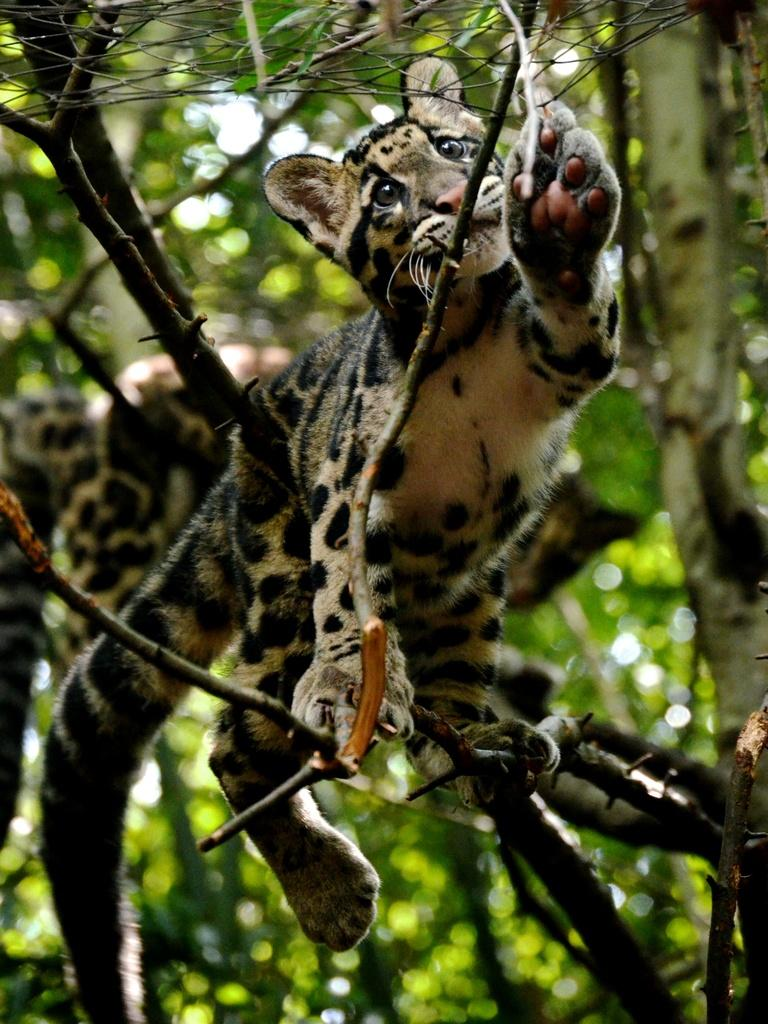What type of creature is in the image? There is an animal in the image. Where is the animal located? The animal is on a tree. How many lizards are involved in the decision-making process in the image? There are no lizards or decision-making processes depicted in the image; it features an animal on a tree. 